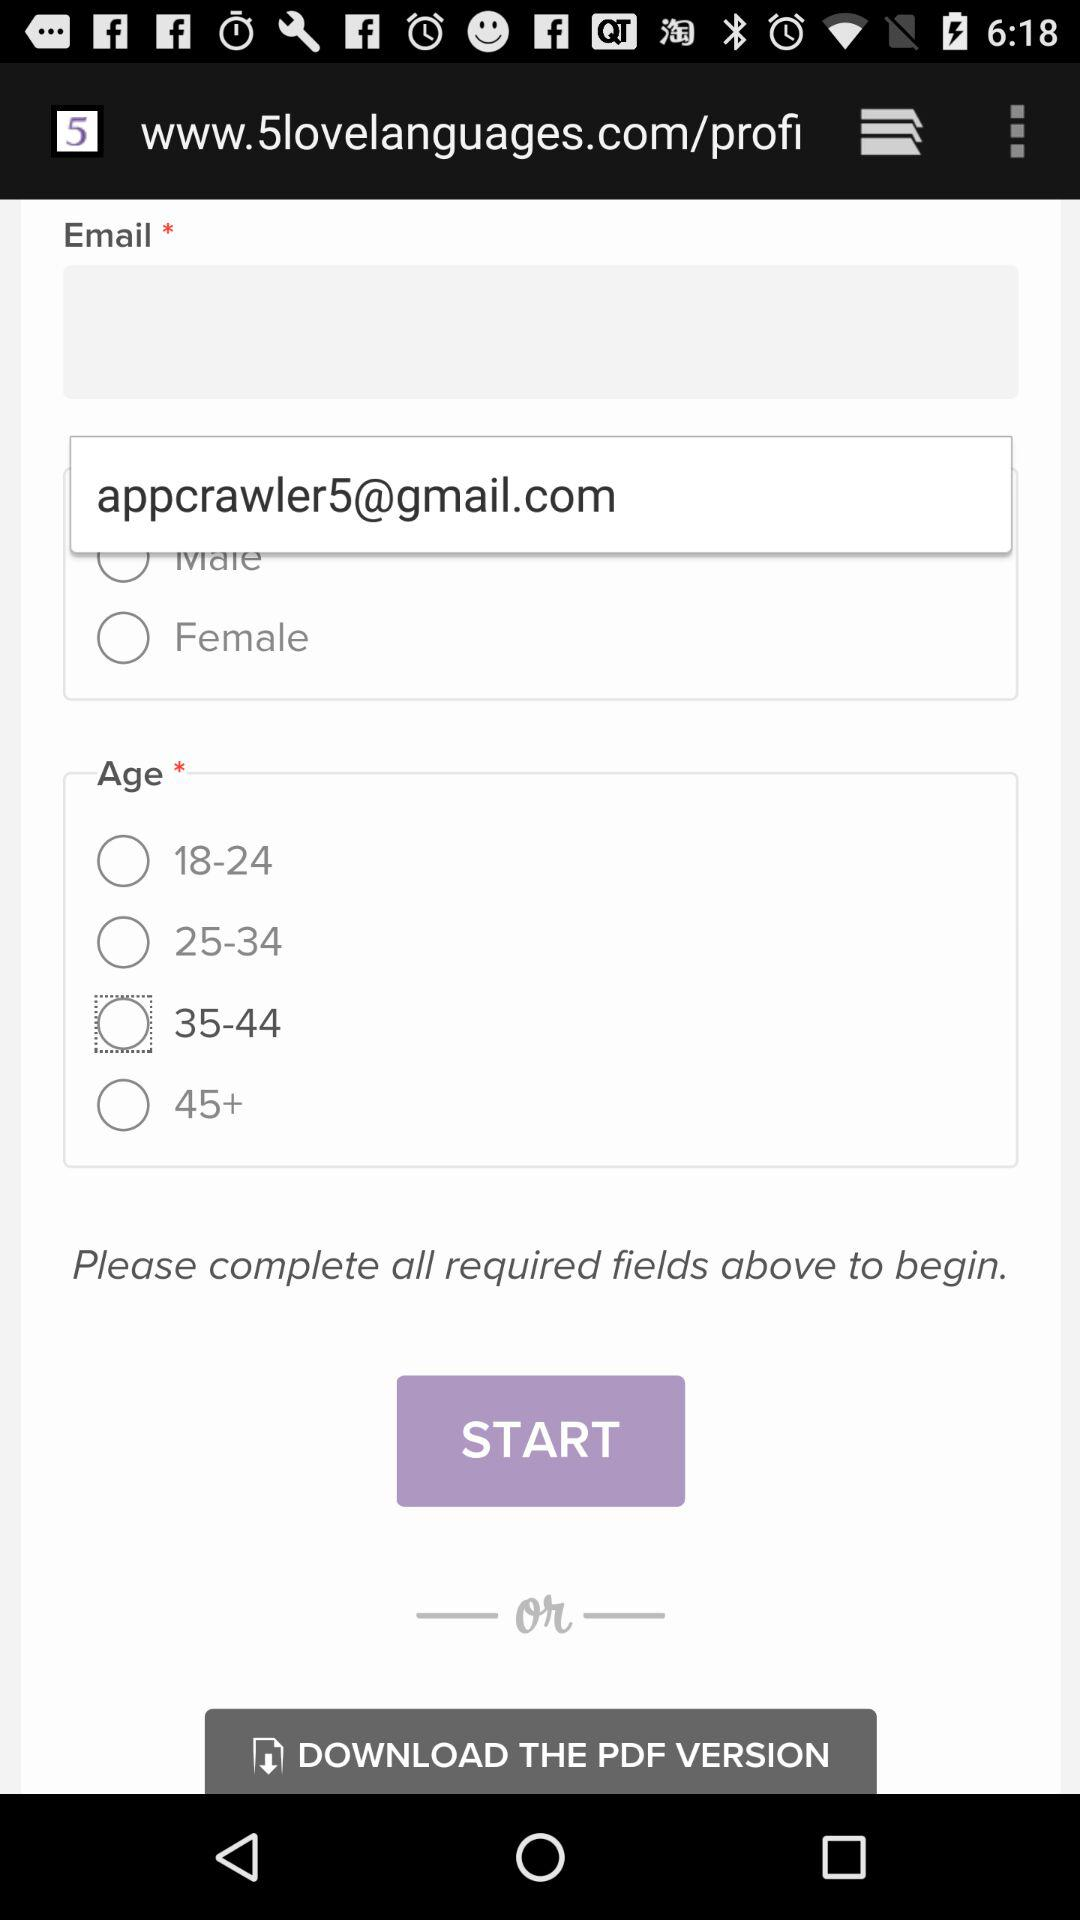Which option has been selected? The selected option is "35-44". 